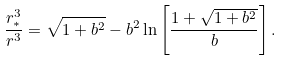<formula> <loc_0><loc_0><loc_500><loc_500>\frac { r _ { * } ^ { 3 } } { r ^ { 3 } } = \sqrt { 1 + b ^ { 2 } } - b ^ { 2 } \ln \left [ \frac { 1 + \sqrt { 1 + b ^ { 2 } } } { b } \right ] .</formula> 